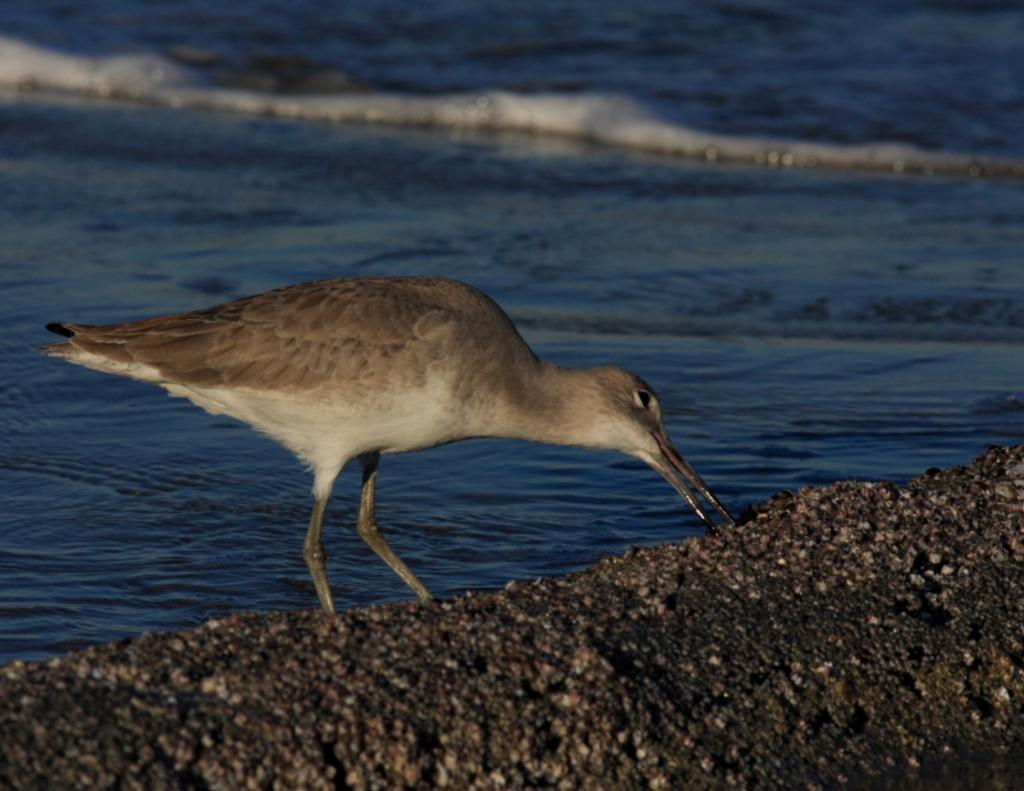What type of bird can be seen in the image? There is a grey and white colored bird in the image. What is visible in the background of the image? Water is visible in the background of the image. What type of lumber is being used to build the rabbit's hutch in the image? There is no rabbit or hutch present in the image, and therefore no lumber can be observed. 